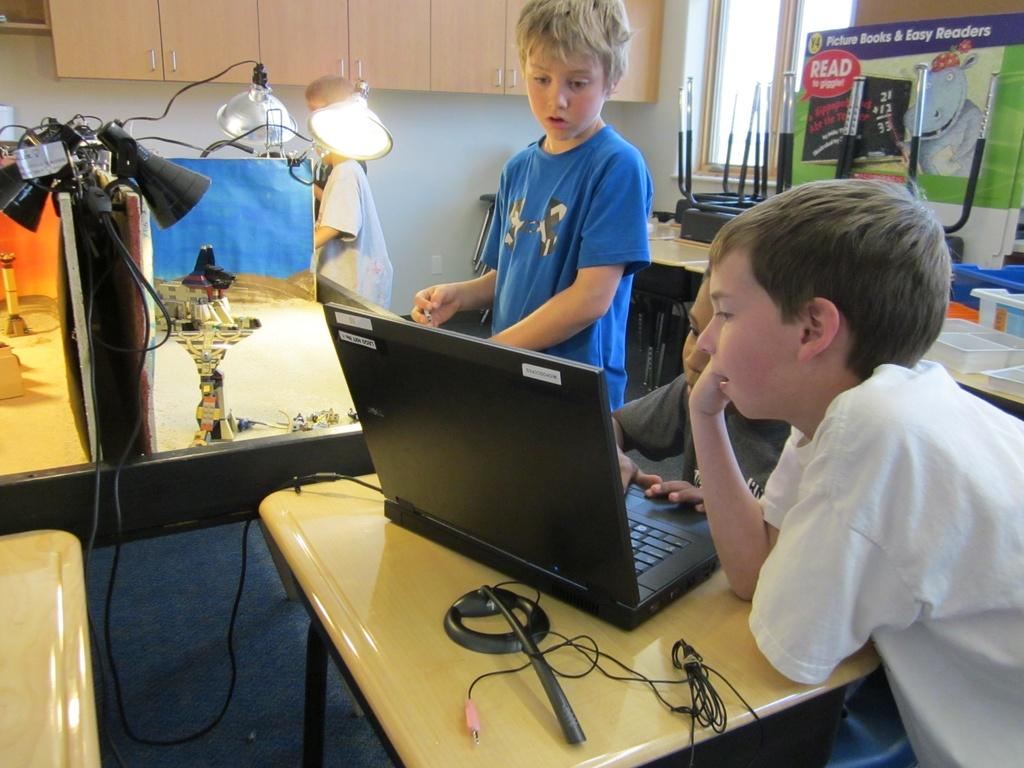<image>
Offer a succinct explanation of the picture presented. children looking at a laptop with a read to giggle sign in the background 